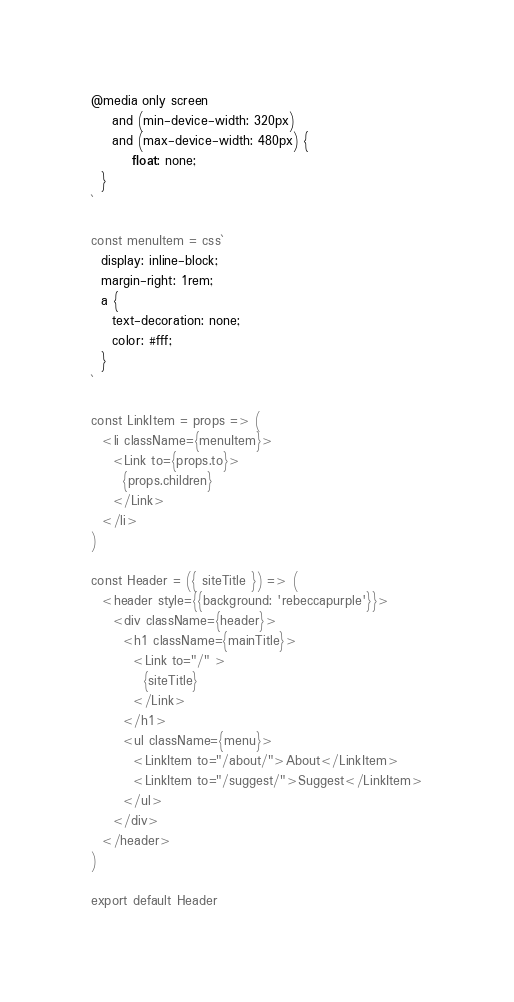Convert code to text. <code><loc_0><loc_0><loc_500><loc_500><_JavaScript_>@media only screen 
	and (min-device-width: 320px) 
	and (max-device-width: 480px) {
		float: none;  
  }
`

const menuItem = css`
  display: inline-block;
  margin-right: 1rem;
  a {
    text-decoration: none;
    color: #fff;
  }
`

const LinkItem = props => (
  <li className={menuItem}>
    <Link to={props.to}>
      {props.children}
    </Link>
  </li>
)

const Header = ({ siteTitle }) => (
  <header style={{background: 'rebeccapurple'}}>
    <div className={header}>
      <h1 className={mainTitle}>
        <Link to="/" >
          {siteTitle}
        </Link>
      </h1>
      <ul className={menu}>
        <LinkItem to="/about/">About</LinkItem>
        <LinkItem to="/suggest/">Suggest</LinkItem>
      </ul>
    </div>
  </header>
)

export default Header
</code> 